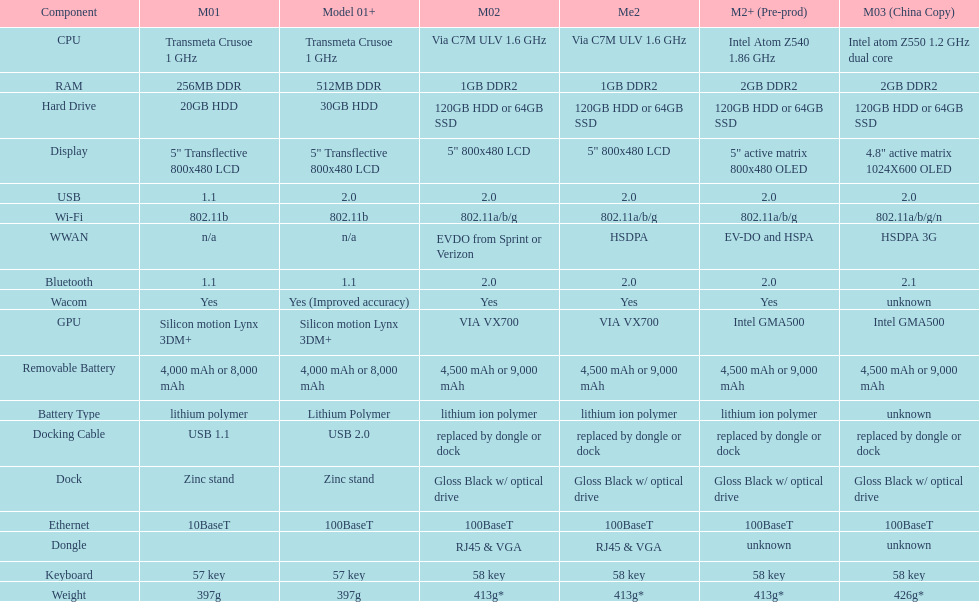How many models use a usb docking cable? 2. 